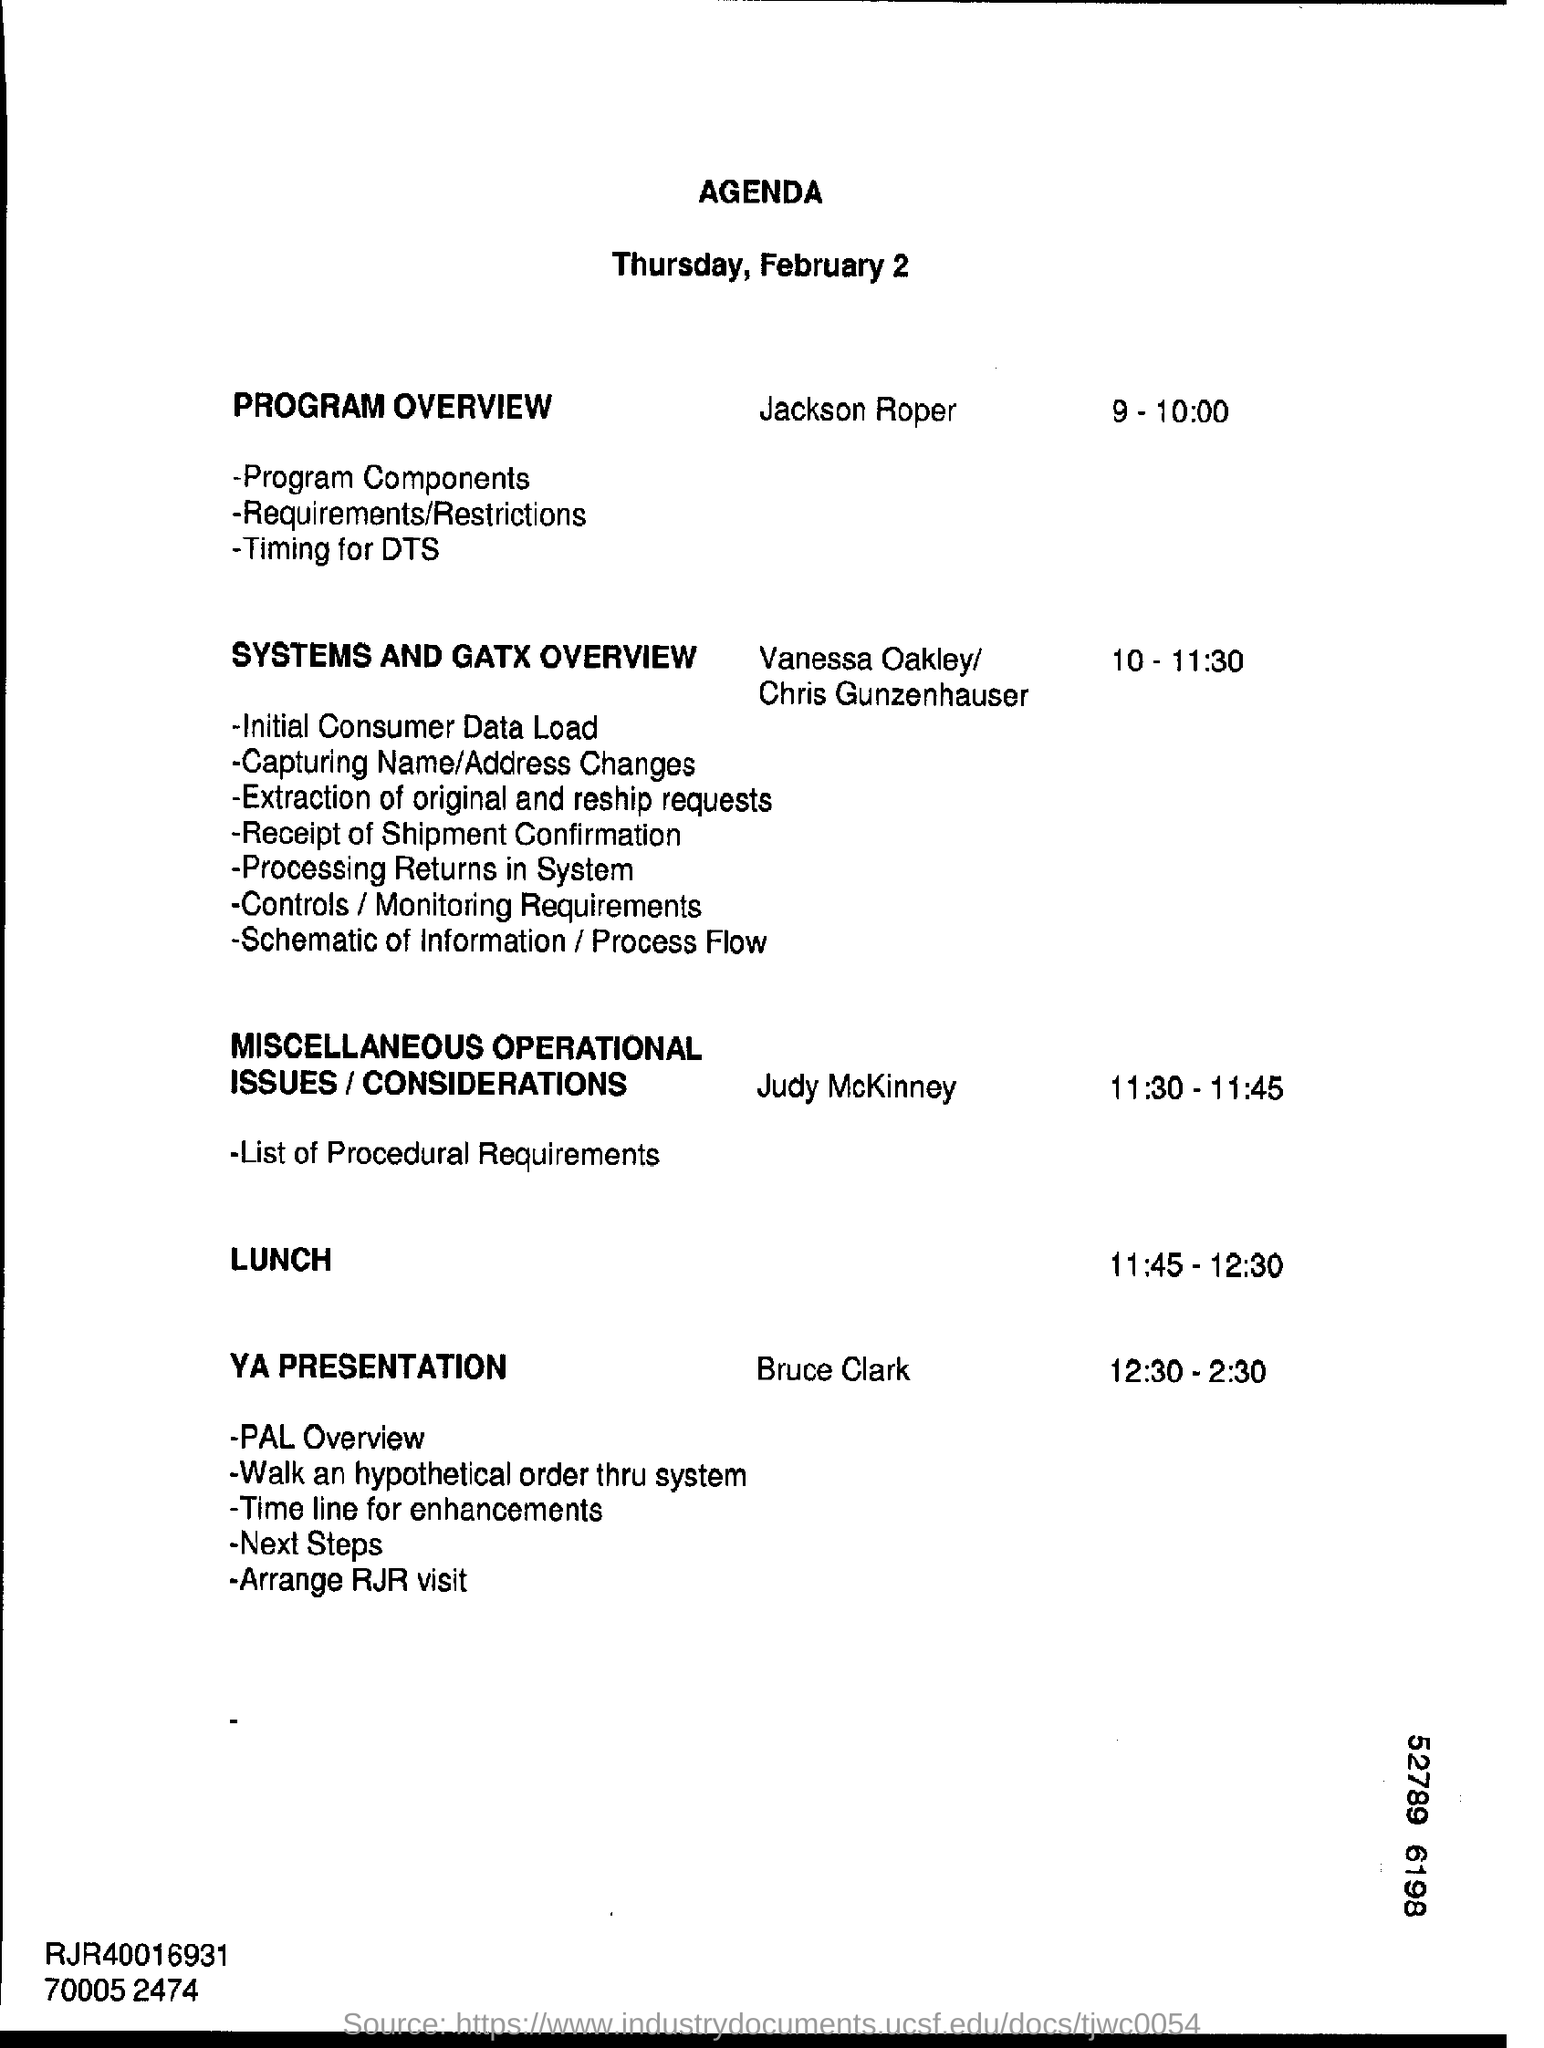What is the date mention in the document?
Your response must be concise. Thursday, February 2. 